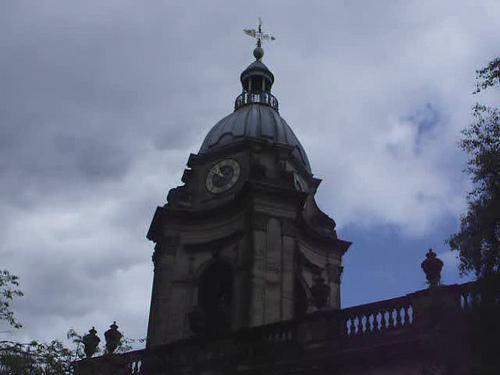Question: how many towers are there?
Choices:
A. 12.
B. 13.
C. 5.
D. 1.
Answer with the letter. Answer: D Question: why is is so dark?
Choices:
A. It's very cloudy.
B. Night.
C. Solar eclipse.
D. The lights are dim.
Answer with the letter. Answer: A Question: what is on the top of the dome?
Choices:
A. A clock.
B. A cross.
C. A bird.
D. S window.
Answer with the letter. Answer: B 